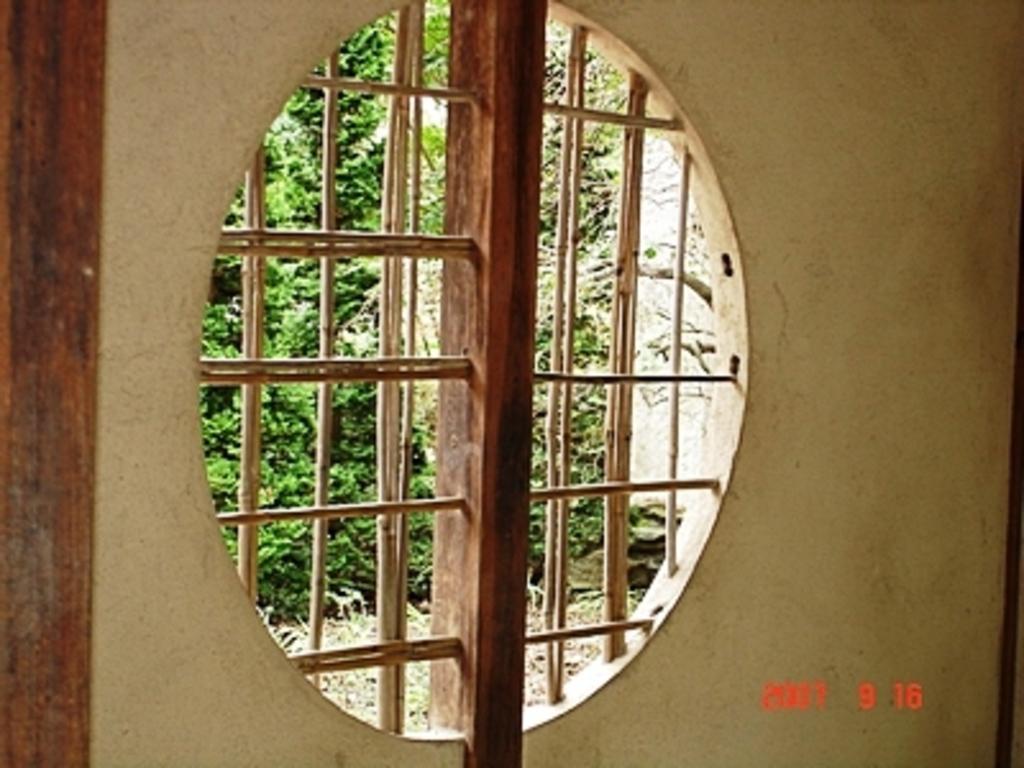Please provide a concise description of this image. In the center of the image there is a window. Through which we can see trees. There is a wall. At the bottom of the image there is some text. 